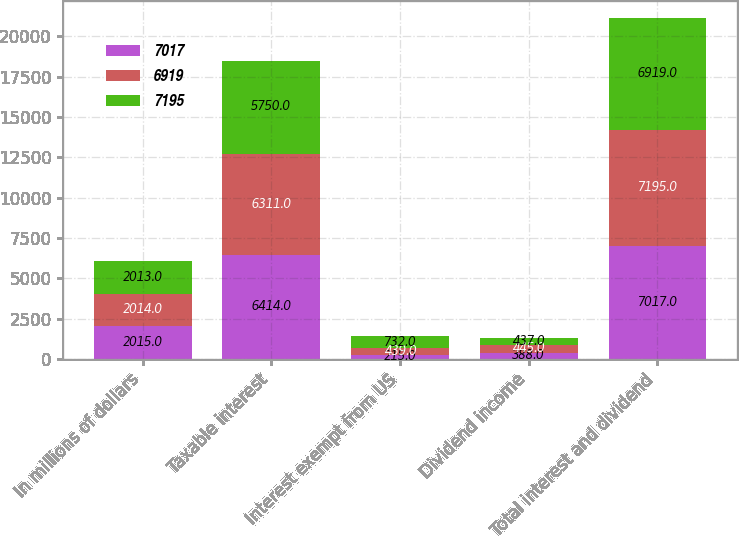Convert chart. <chart><loc_0><loc_0><loc_500><loc_500><stacked_bar_chart><ecel><fcel>In millions of dollars<fcel>Taxable interest<fcel>Interest exempt from US<fcel>Dividend income<fcel>Total interest and dividend<nl><fcel>7017<fcel>2015<fcel>6414<fcel>215<fcel>388<fcel>7017<nl><fcel>6919<fcel>2014<fcel>6311<fcel>439<fcel>445<fcel>7195<nl><fcel>7195<fcel>2013<fcel>5750<fcel>732<fcel>437<fcel>6919<nl></chart> 